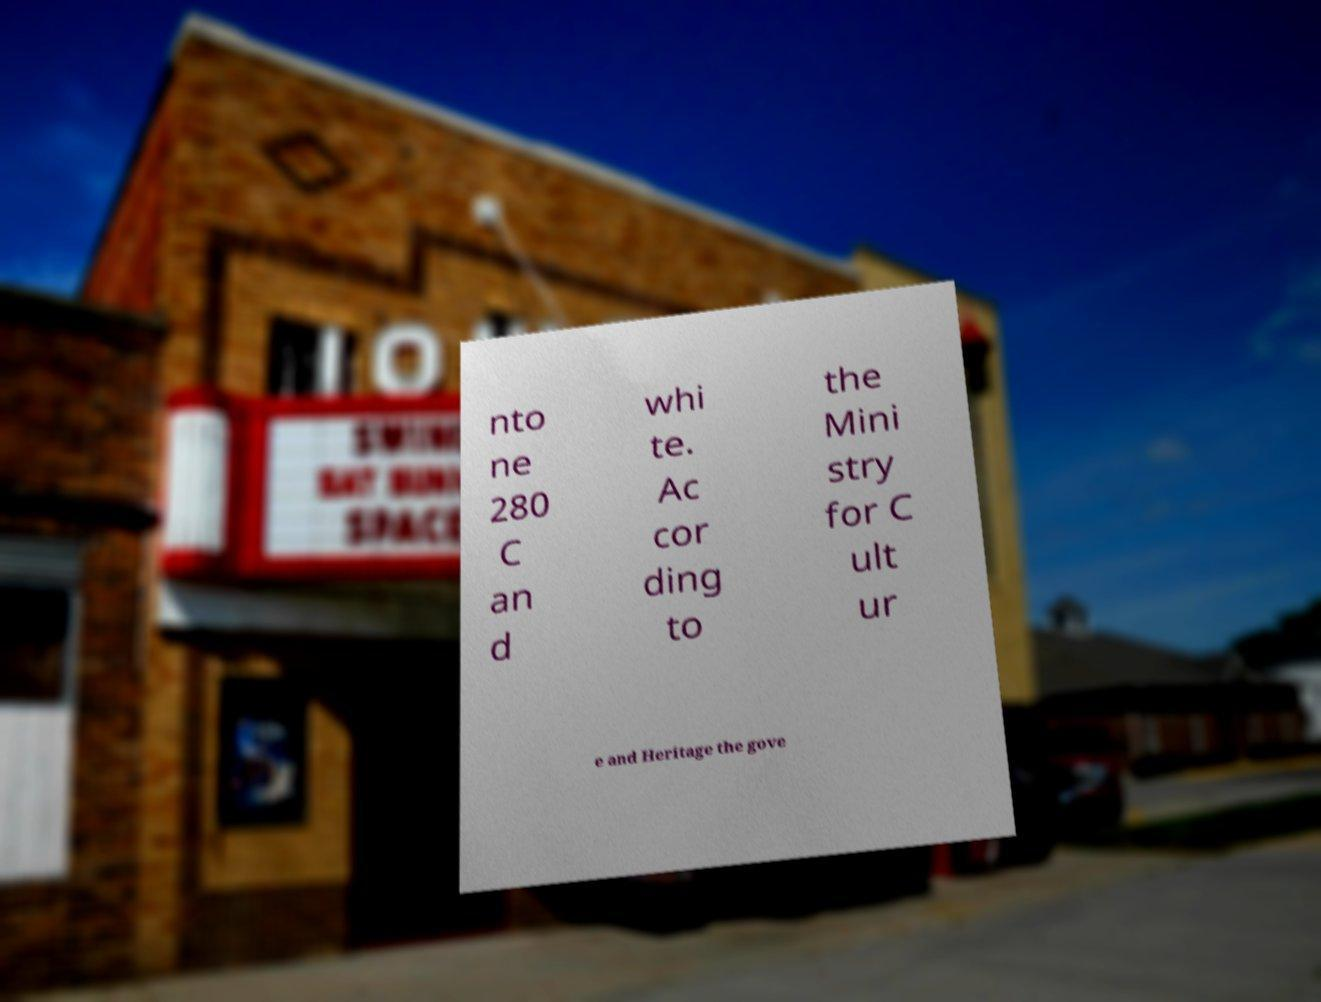For documentation purposes, I need the text within this image transcribed. Could you provide that? nto ne 280 C an d whi te. Ac cor ding to the Mini stry for C ult ur e and Heritage the gove 